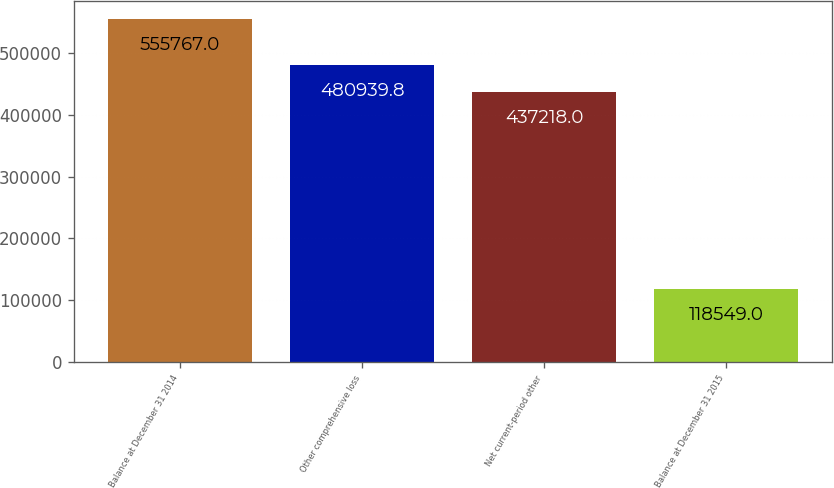Convert chart. <chart><loc_0><loc_0><loc_500><loc_500><bar_chart><fcel>Balance at December 31 2014<fcel>Other comprehensive loss<fcel>Net current-period other<fcel>Balance at December 31 2015<nl><fcel>555767<fcel>480940<fcel>437218<fcel>118549<nl></chart> 